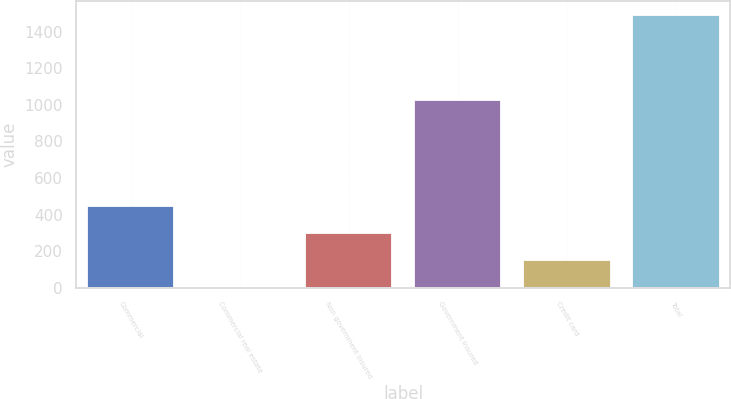<chart> <loc_0><loc_0><loc_500><loc_500><bar_chart><fcel>Commercial<fcel>Commercial real estate<fcel>Non government insured<fcel>Government insured<fcel>Credit card<fcel>Total<nl><fcel>448.7<fcel>2<fcel>299.8<fcel>1025<fcel>150.9<fcel>1491<nl></chart> 